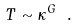Convert formula to latex. <formula><loc_0><loc_0><loc_500><loc_500>T \sim \kappa ^ { G } \ .</formula> 